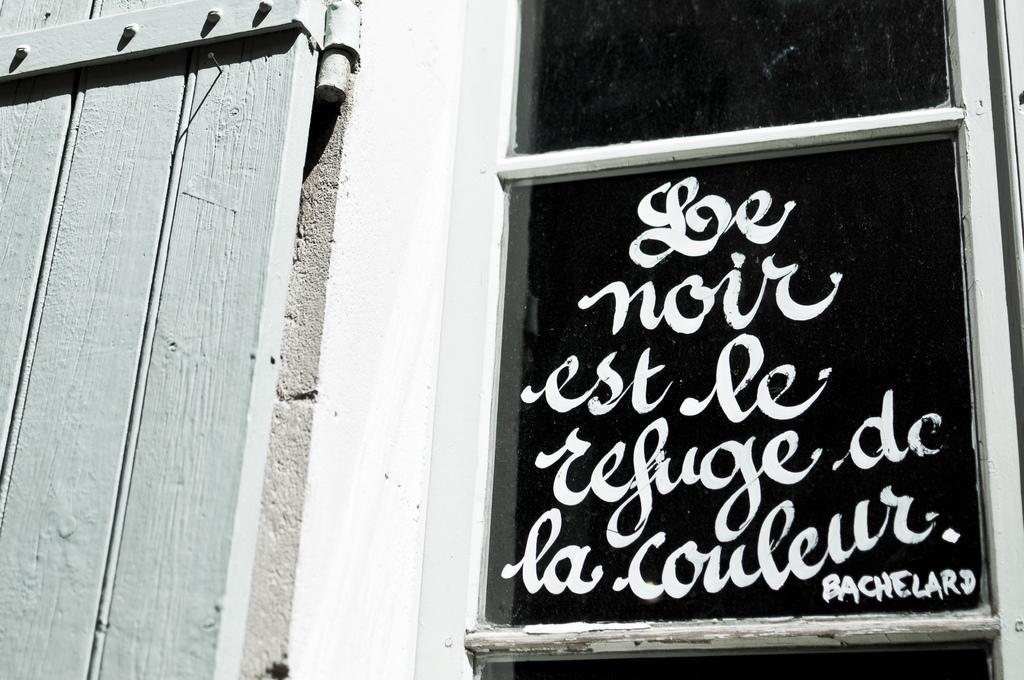Could you give a brief overview of what you see in this image? In this image we can see some text written on the glass of a window, beside the window there is a wooden door. 